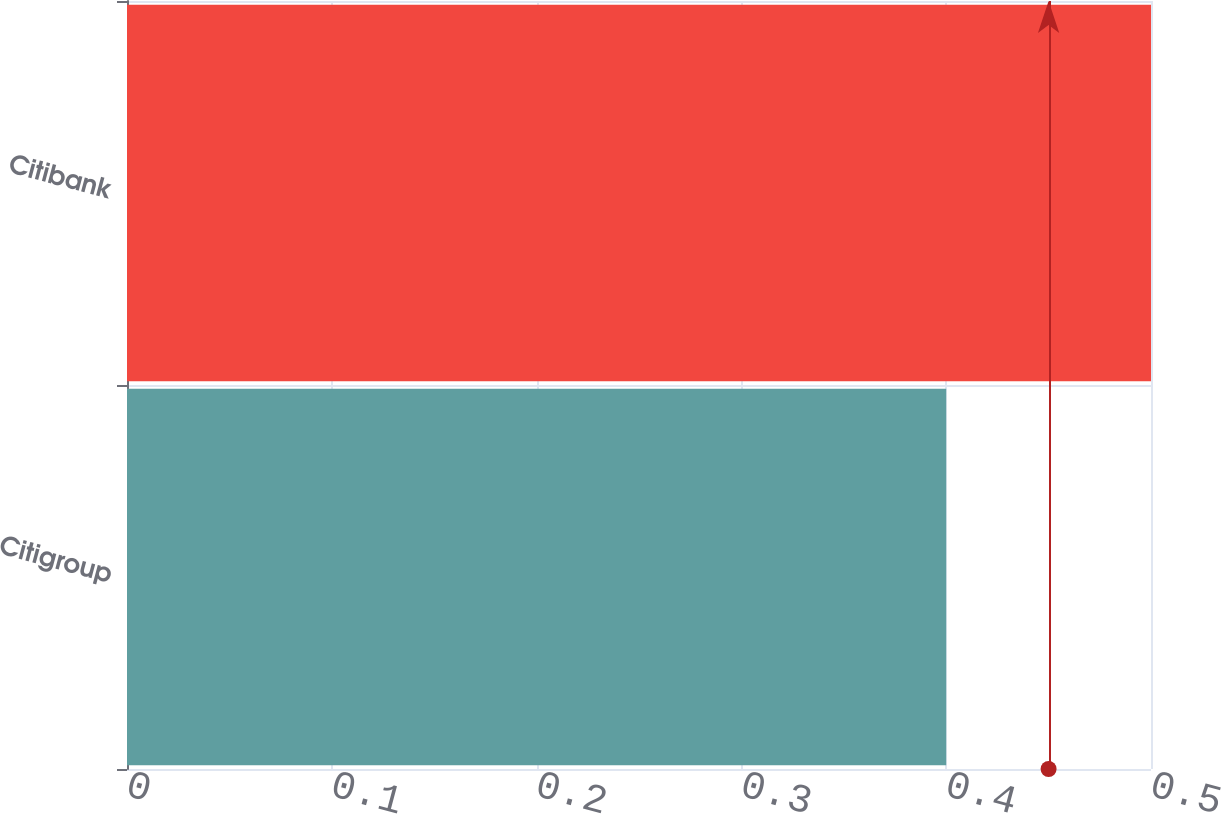Convert chart to OTSL. <chart><loc_0><loc_0><loc_500><loc_500><bar_chart><fcel>Citigroup<fcel>Citibank<nl><fcel>0.4<fcel>0.5<nl></chart> 